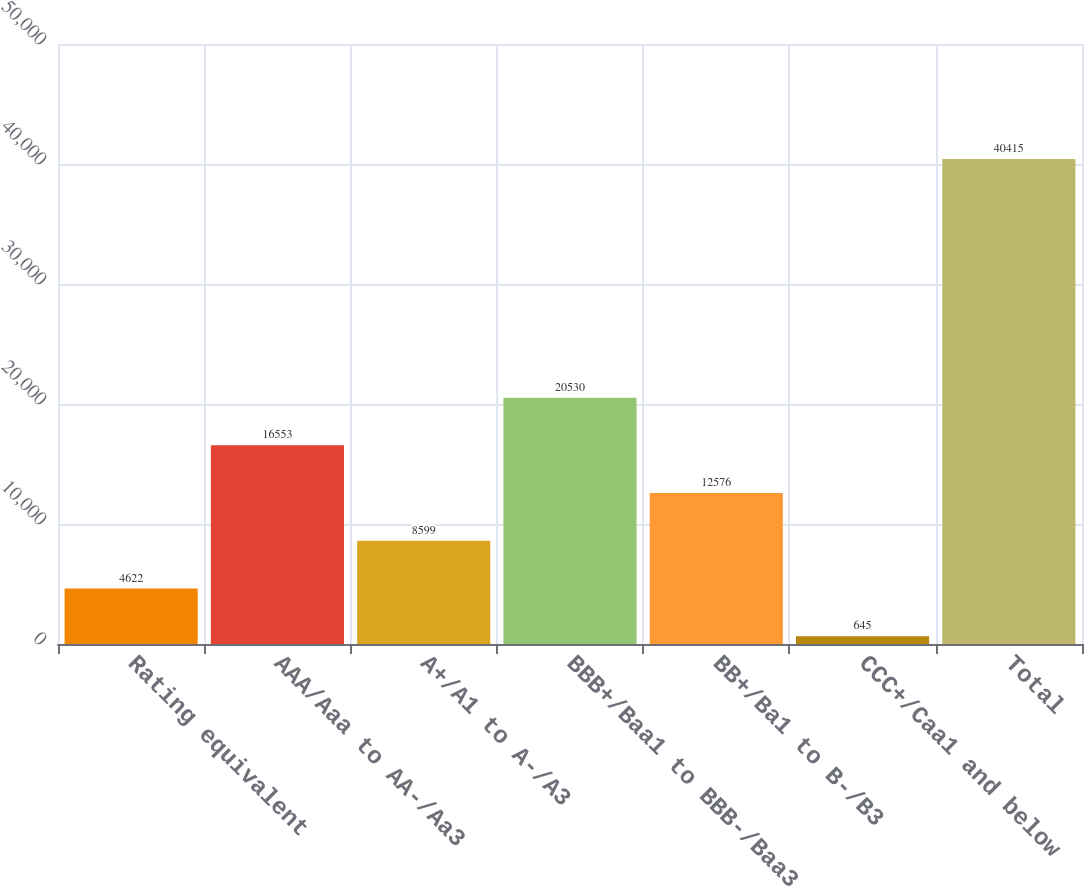<chart> <loc_0><loc_0><loc_500><loc_500><bar_chart><fcel>Rating equivalent<fcel>AAA/Aaa to AA-/Aa3<fcel>A+/A1 to A-/A3<fcel>BBB+/Baa1 to BBB-/Baa3<fcel>BB+/Ba1 to B-/B3<fcel>CCC+/Caa1 and below<fcel>Total<nl><fcel>4622<fcel>16553<fcel>8599<fcel>20530<fcel>12576<fcel>645<fcel>40415<nl></chart> 